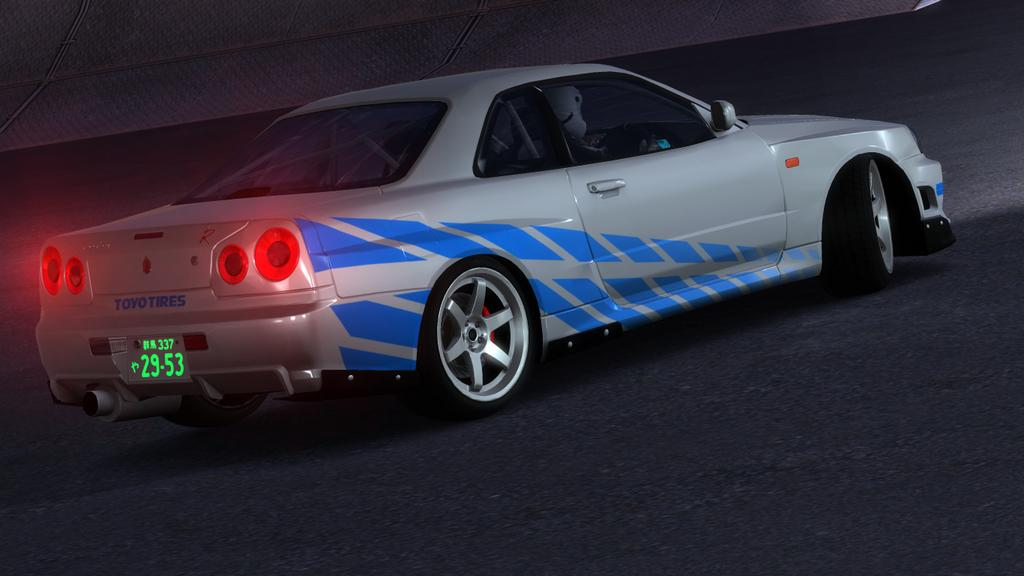What is the main subject of the image? The main subject of the image is a car on the road. Can you describe the car's location in the image? The car is on the road in the image. Is there anyone inside the car? Yes, there is a person inside the car. What is present at the side of the road in the image? There is a wall at the side of the road in the image. What book is the person inside the car reading in the image? There is no book or reading activity present in the image. 